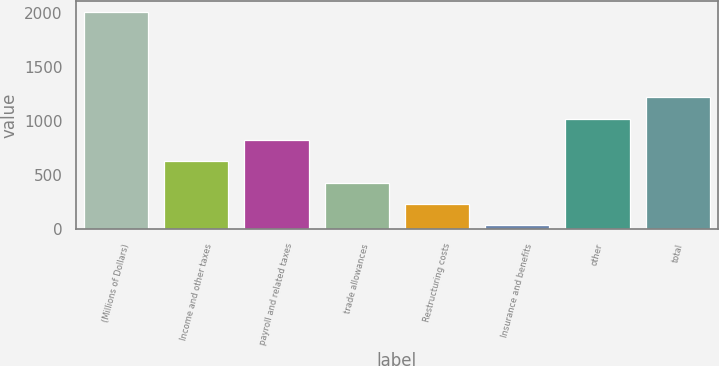Convert chart. <chart><loc_0><loc_0><loc_500><loc_500><bar_chart><fcel>(Millions of Dollars)<fcel>Income and other taxes<fcel>payroll and related taxes<fcel>trade allowances<fcel>Restructuring costs<fcel>Insurance and benefits<fcel>other<fcel>total<nl><fcel>2006<fcel>626.3<fcel>823.4<fcel>429.2<fcel>232.1<fcel>35<fcel>1020.5<fcel>1217.6<nl></chart> 